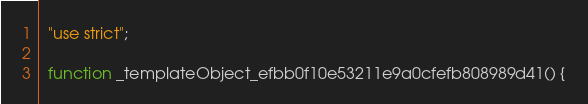Convert code to text. <code><loc_0><loc_0><loc_500><loc_500><_JavaScript_>  "use strict";

  function _templateObject_efbb0f10e53211e9a0cfefb808989d41() {</code> 